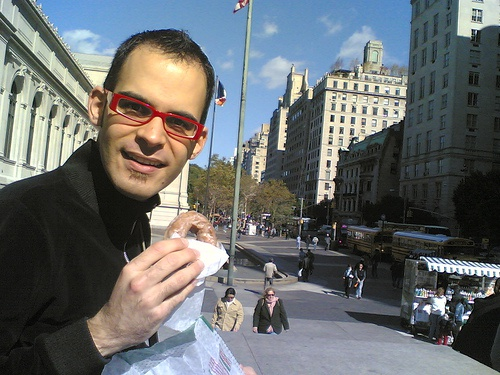Describe the objects in this image and their specific colors. I can see people in darkgray, black, and tan tones, bus in darkgray, black, gray, and blue tones, donut in darkgray, tan, and white tones, bus in darkgray, black, and gray tones, and people in darkgray, black, gray, and purple tones in this image. 